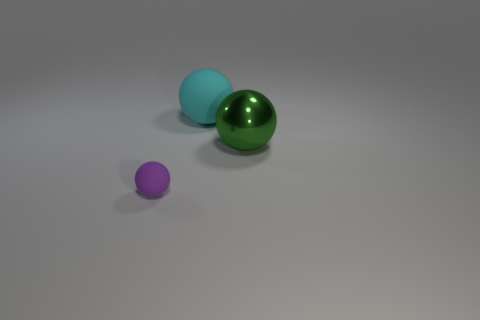Is there a matte thing that has the same color as the shiny ball?
Make the answer very short. No. There is a metallic thing that is the same size as the cyan rubber ball; what color is it?
Your answer should be compact. Green. Is there a big rubber ball behind the large sphere that is behind the big green shiny sphere?
Give a very brief answer. No. What is the material of the tiny purple ball in front of the big green thing?
Give a very brief answer. Rubber. Is the large sphere that is right of the large matte sphere made of the same material as the small sphere that is to the left of the cyan thing?
Offer a terse response. No. Is the number of purple rubber spheres on the right side of the big matte ball the same as the number of tiny balls that are behind the purple ball?
Make the answer very short. Yes. What number of large yellow cylinders have the same material as the large cyan thing?
Provide a short and direct response. 0. There is a sphere in front of the big thing that is right of the cyan thing; how big is it?
Ensure brevity in your answer.  Small. There is a purple thing that is on the left side of the big cyan thing; does it have the same shape as the rubber object that is on the right side of the tiny purple rubber object?
Provide a short and direct response. Yes. Is the number of small balls that are in front of the green sphere the same as the number of large cyan shiny objects?
Offer a terse response. No. 